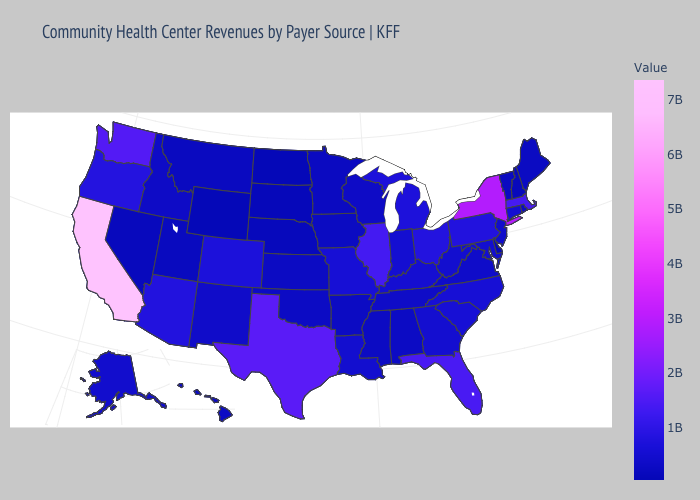Which states hav the highest value in the Northeast?
Short answer required. New York. Which states have the lowest value in the USA?
Concise answer only. Wyoming. Does Texas have a lower value than North Carolina?
Concise answer only. No. Among the states that border Florida , does Alabama have the lowest value?
Write a very short answer. Yes. Does California have the highest value in the USA?
Concise answer only. Yes. 